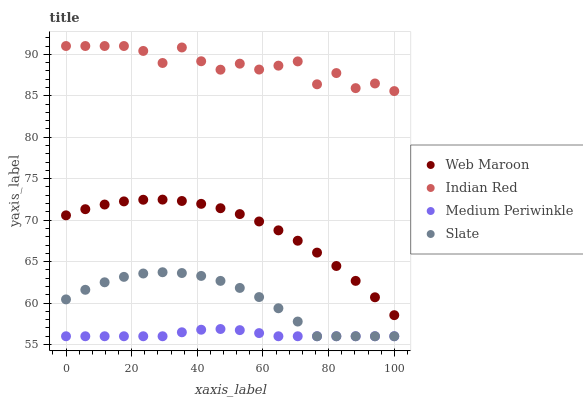Does Medium Periwinkle have the minimum area under the curve?
Answer yes or no. Yes. Does Indian Red have the maximum area under the curve?
Answer yes or no. Yes. Does Slate have the minimum area under the curve?
Answer yes or no. No. Does Slate have the maximum area under the curve?
Answer yes or no. No. Is Medium Periwinkle the smoothest?
Answer yes or no. Yes. Is Indian Red the roughest?
Answer yes or no. Yes. Is Slate the smoothest?
Answer yes or no. No. Is Slate the roughest?
Answer yes or no. No. Does Medium Periwinkle have the lowest value?
Answer yes or no. Yes. Does Web Maroon have the lowest value?
Answer yes or no. No. Does Indian Red have the highest value?
Answer yes or no. Yes. Does Slate have the highest value?
Answer yes or no. No. Is Web Maroon less than Indian Red?
Answer yes or no. Yes. Is Indian Red greater than Medium Periwinkle?
Answer yes or no. Yes. Does Slate intersect Medium Periwinkle?
Answer yes or no. Yes. Is Slate less than Medium Periwinkle?
Answer yes or no. No. Is Slate greater than Medium Periwinkle?
Answer yes or no. No. Does Web Maroon intersect Indian Red?
Answer yes or no. No. 